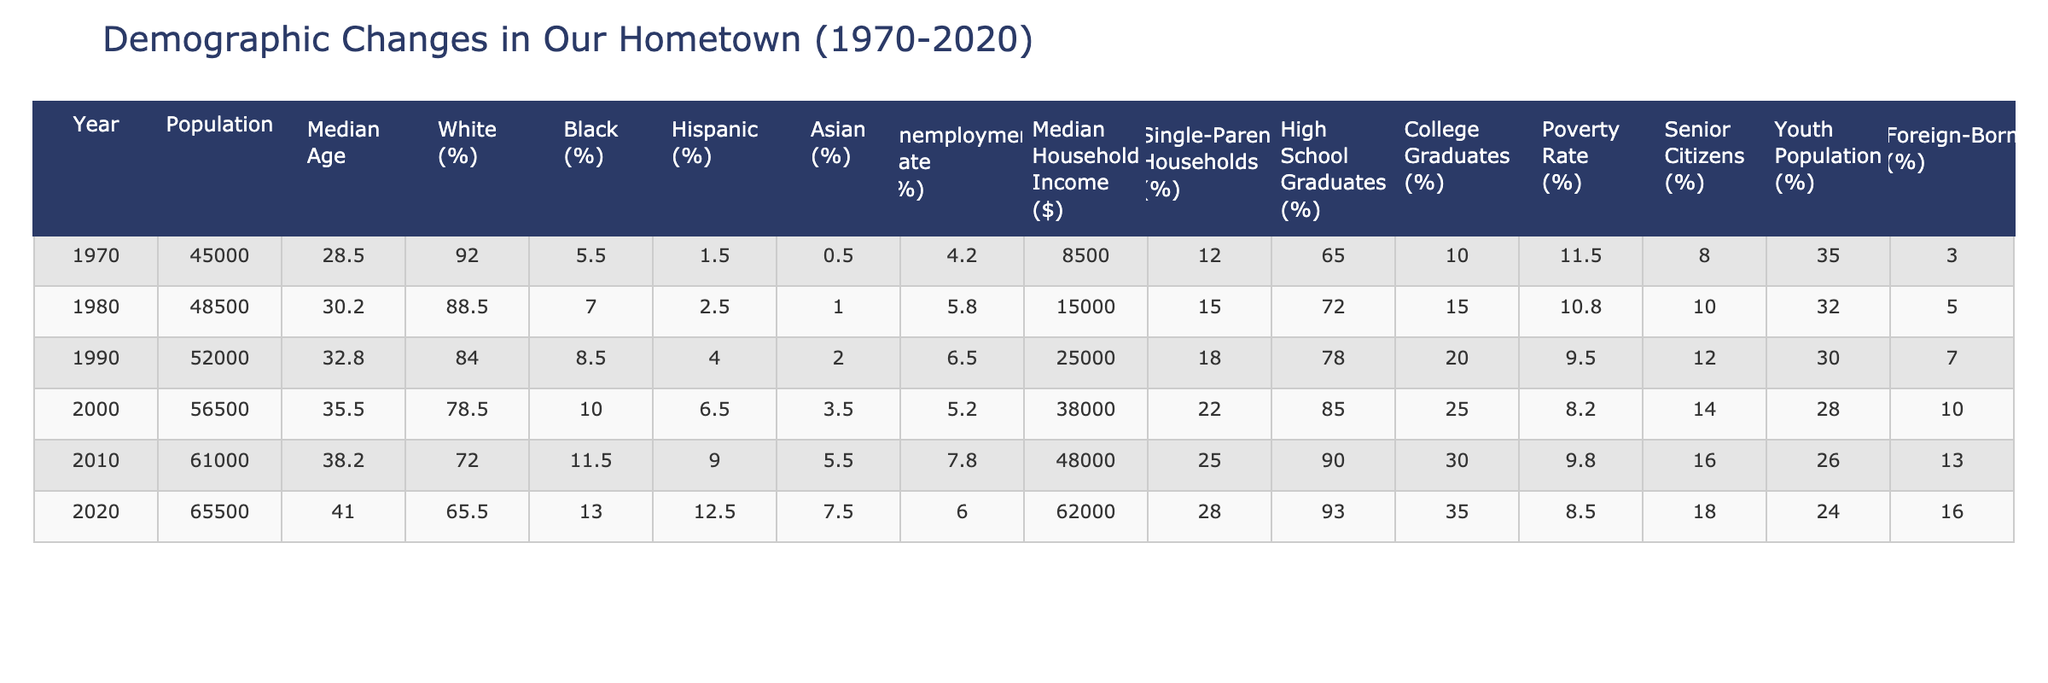What was the population in 2000? Referring to the table, the population for the year 2000 is directly listed in the corresponding row, which is 56,500.
Answer: 56,500 What is the median age in 1970? Looking at the row for 1970, the median age is provided as 28.5 years.
Answer: 28.5 How much did the median household income increase from 1980 to 2020? The median household income in 1980 is $15,000 and in 2020 it is $62,000. The difference is calculated as $62,000 - $15,000 = $47,000.
Answer: $47,000 What percentage of the population was foreign-born in 1990? The table shows that the foreign-born percentage in 1990 is 7%.
Answer: 7% Did the unemployment rate increase or decrease from 2000 to 2010? The unemployment rate in 2000 is 5.2% and in 2010 it is 7.8%. Since 7.8% is higher than 5.2%, it indicates an increase.
Answer: Increase What is the difference in the percentage of Black population from 1970 to 2020? The percentage of Black population in 1970 is 5.5%, and in 2020 it is 13%. The difference is calculated as 13% - 5.5% = 7.5%.
Answer: 7.5% What is the average median age from 1970 to 2020? To find the average, sum the median age values across the years (28.5 + 30.2 + 32.8 + 35.5 + 38.2 + 41.0) = 205.2, and then divide by the total years (6), giving an average of 34.2 years.
Answer: 34.2 Has the percentage of high school graduates increased over the years? By comparing the high school graduation rates provided for each decade: 65%, 72%, 78%, 85%, 90%, and 93%, it's clear that the percentage has consistently increased over the years.
Answer: Yes What's the percentage increase in the senior citizens' population from 1970 to 2020? The percentage of senior citizens in 1970 is 8% and in 2020 is 18%. The increase is calculated as 18% - 8% = 10%.
Answer: 10% What is the trend in single-parent households from 1970 to 2020? The percentages in the years show an increase from 12% in 1970 to 28% in 2020. This indicates a general upward trend in the percentage of single-parent households.
Answer: Upward trend Was there a decrease in the youth population from 1970 to 2020? The youth population percentages are 35% in 1970 and 24% in 2020. Since 24% is less than 35%, this indicates a decrease.
Answer: Yes, there was a decrease 